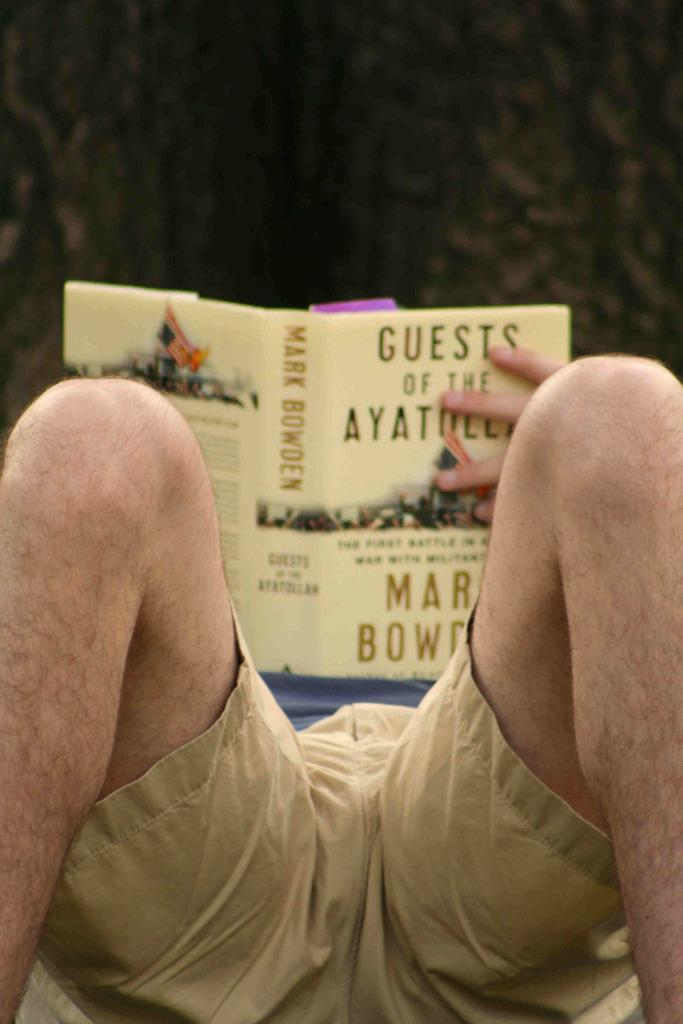What is the main subject of the image? There is a man in the image. What is the man holding in the image? The man is holding a book. Can you describe the background of the image? The background of the image is blurry. What type of dress is the man wearing in the image? The man is not wearing a dress in the image; he is wearing clothing appropriate for a man. What type of hose is visible in the image? There are no hoses present in the image. 